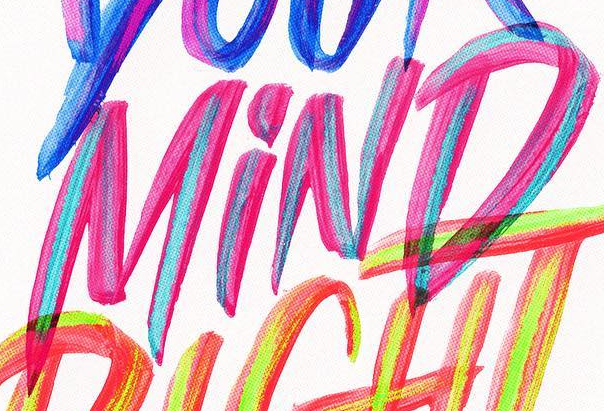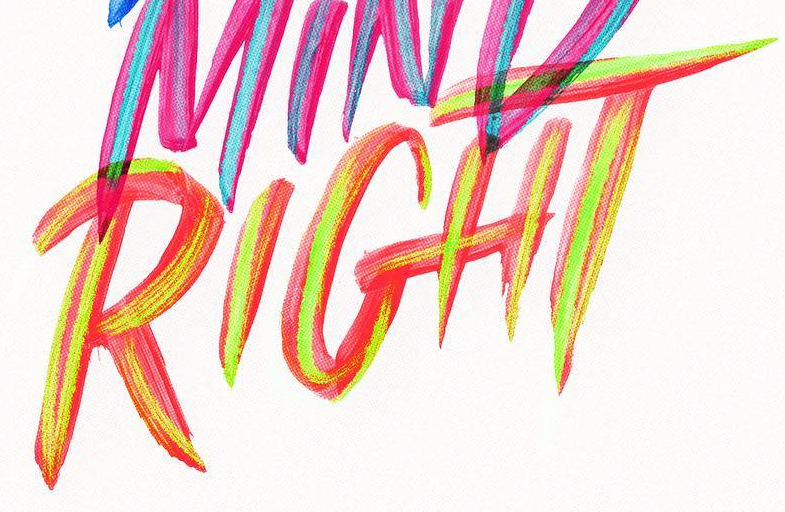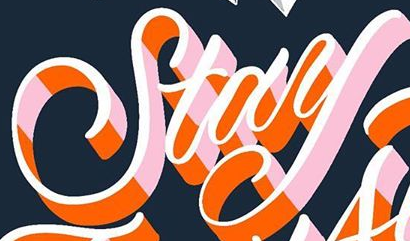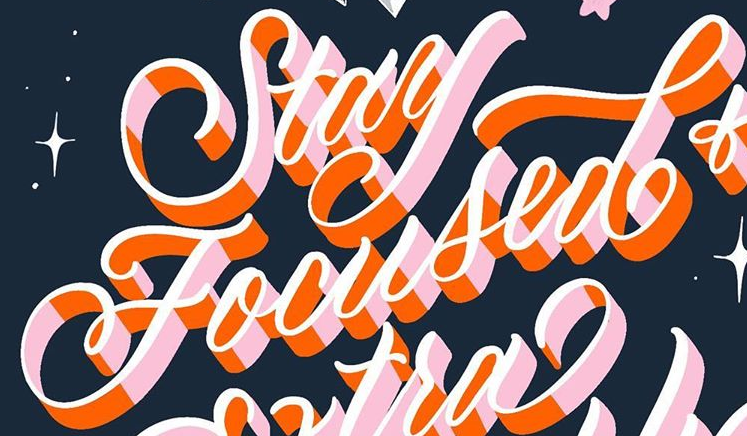What text appears in these images from left to right, separated by a semicolon? MiND; RIGHT; Stay; Focused 